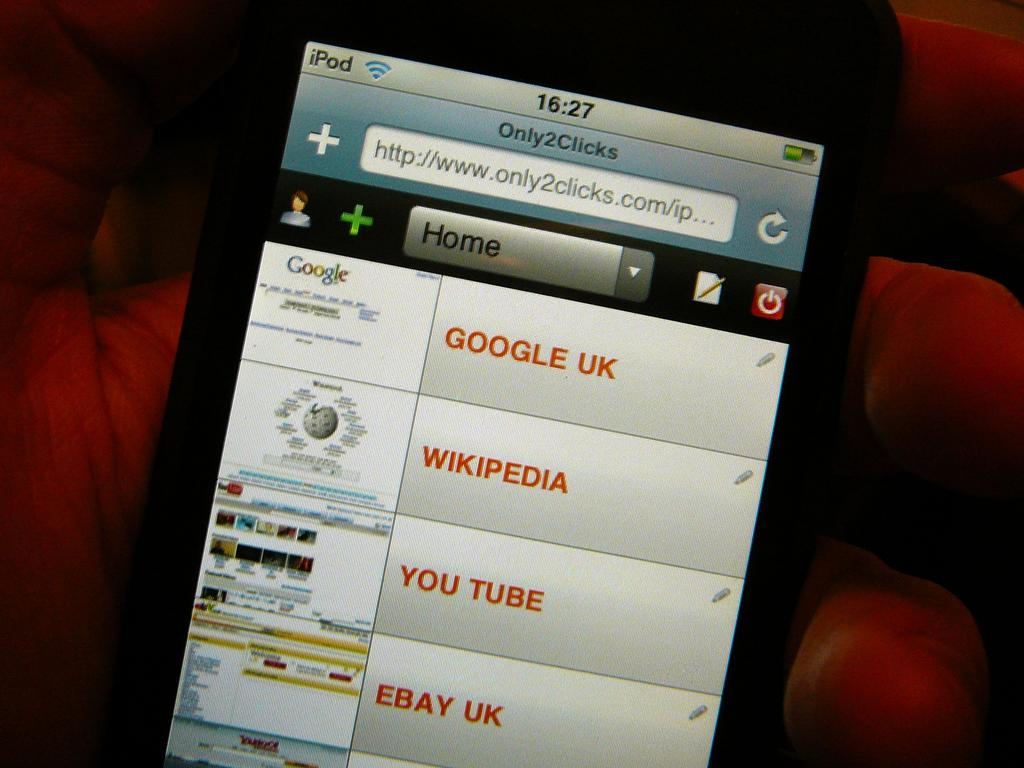<image>
Create a compact narrative representing the image presented. a close up of an iPod screen for ONLY2Clicks 